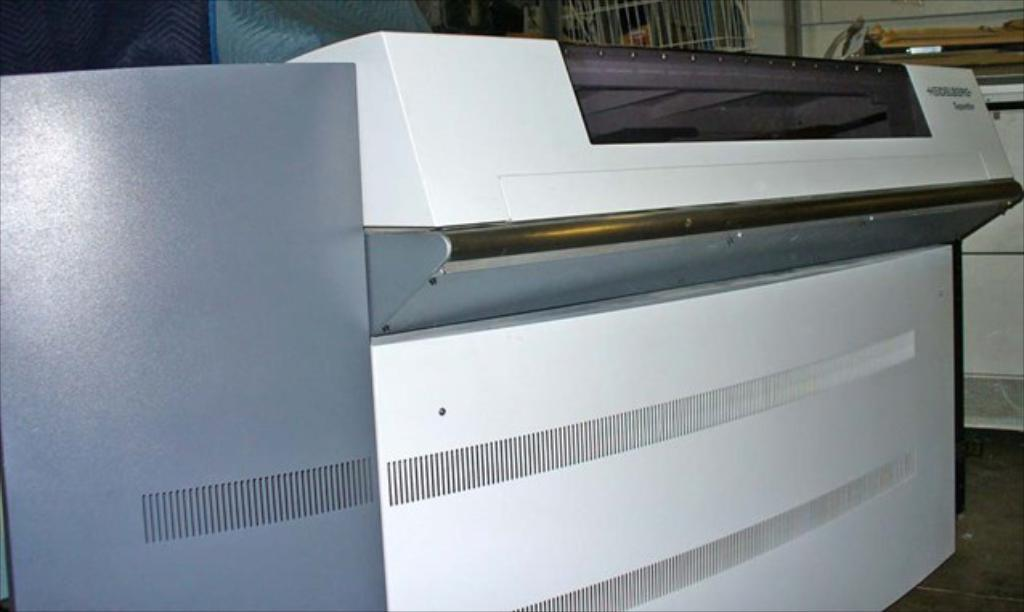What is the main object in the image? There is a machine in the image. Where is the machine located in the image? The machine is in the background of the image. What else can be seen on the floor in the image? There are other objects on the floor in the image. What type of cow can be seen wearing bells in the image? There is no cow or bells present in the image. 